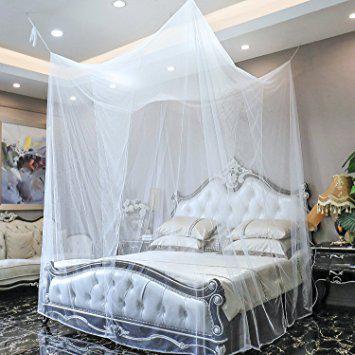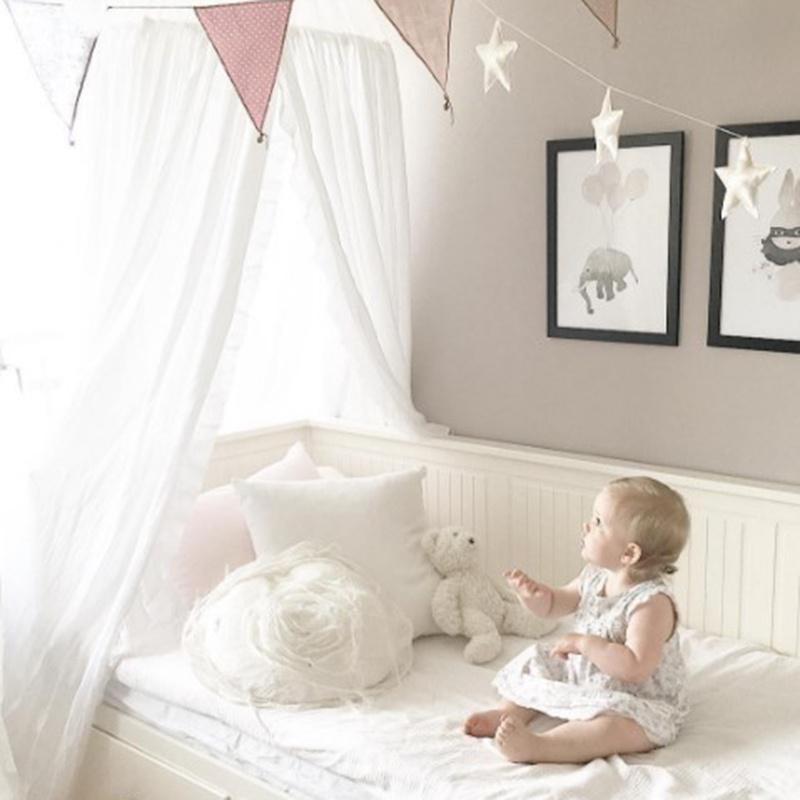The first image is the image on the left, the second image is the image on the right. For the images displayed, is the sentence "There is a baby visible in one image." factually correct? Answer yes or no. Yes. The first image is the image on the left, the second image is the image on the right. Examine the images to the left and right. Is the description "The left and right image contains a total of two open canopies." accurate? Answer yes or no. No. 